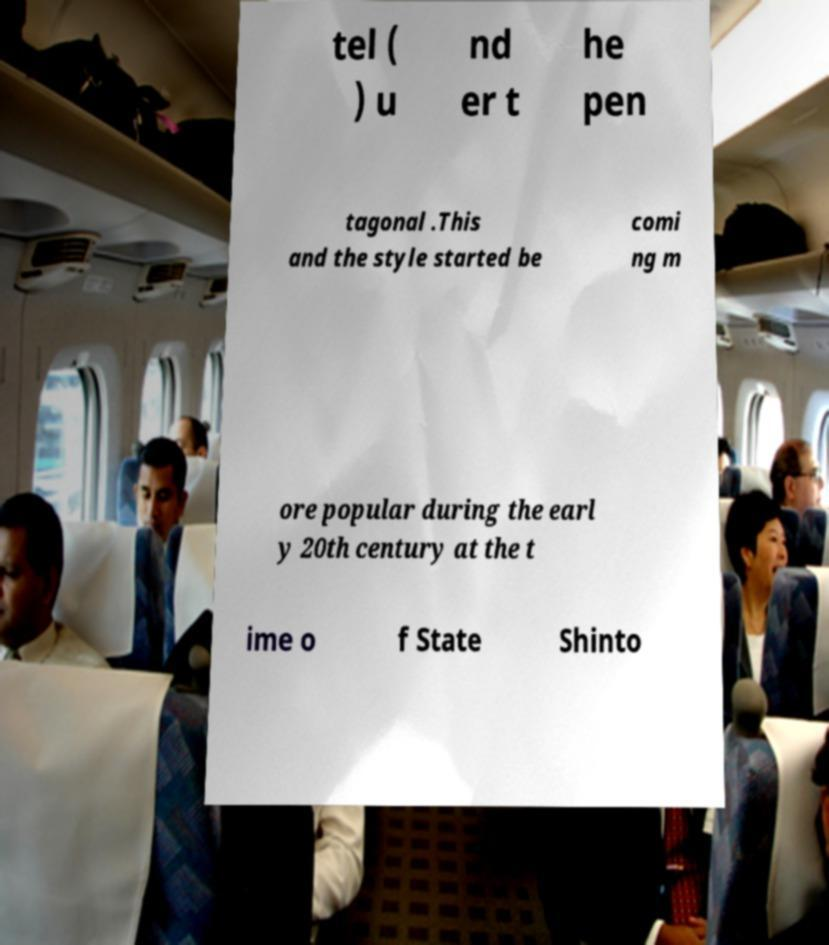Please read and relay the text visible in this image. What does it say? tel ( ) u nd er t he pen tagonal .This and the style started be comi ng m ore popular during the earl y 20th century at the t ime o f State Shinto 